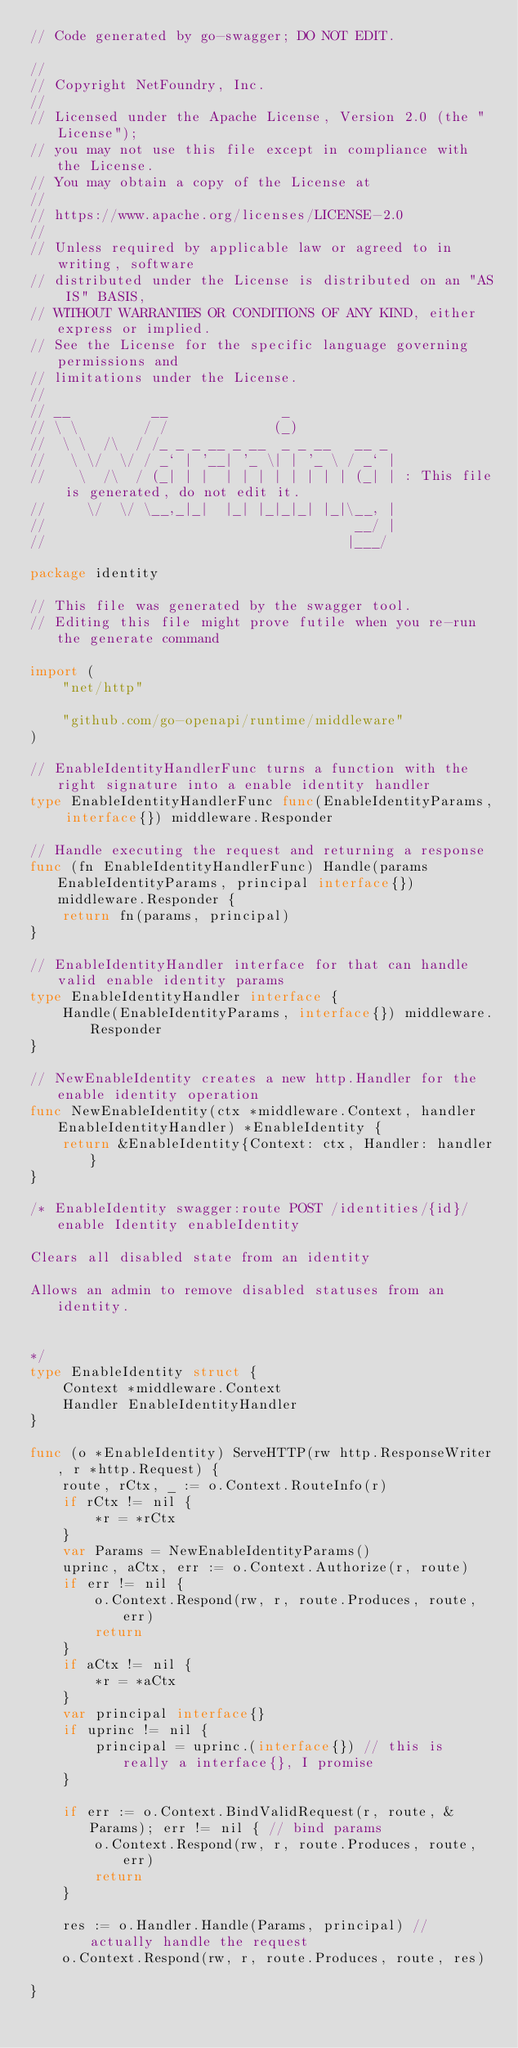Convert code to text. <code><loc_0><loc_0><loc_500><loc_500><_Go_>// Code generated by go-swagger; DO NOT EDIT.

//
// Copyright NetFoundry, Inc.
//
// Licensed under the Apache License, Version 2.0 (the "License");
// you may not use this file except in compliance with the License.
// You may obtain a copy of the License at
//
// https://www.apache.org/licenses/LICENSE-2.0
//
// Unless required by applicable law or agreed to in writing, software
// distributed under the License is distributed on an "AS IS" BASIS,
// WITHOUT WARRANTIES OR CONDITIONS OF ANY KIND, either express or implied.
// See the License for the specific language governing permissions and
// limitations under the License.
//
// __          __              _
// \ \        / /             (_)
//  \ \  /\  / /_ _ _ __ _ __  _ _ __   __ _
//   \ \/  \/ / _` | '__| '_ \| | '_ \ / _` |
//    \  /\  / (_| | |  | | | | | | | | (_| | : This file is generated, do not edit it.
//     \/  \/ \__,_|_|  |_| |_|_|_| |_|\__, |
//                                      __/ |
//                                     |___/

package identity

// This file was generated by the swagger tool.
// Editing this file might prove futile when you re-run the generate command

import (
	"net/http"

	"github.com/go-openapi/runtime/middleware"
)

// EnableIdentityHandlerFunc turns a function with the right signature into a enable identity handler
type EnableIdentityHandlerFunc func(EnableIdentityParams, interface{}) middleware.Responder

// Handle executing the request and returning a response
func (fn EnableIdentityHandlerFunc) Handle(params EnableIdentityParams, principal interface{}) middleware.Responder {
	return fn(params, principal)
}

// EnableIdentityHandler interface for that can handle valid enable identity params
type EnableIdentityHandler interface {
	Handle(EnableIdentityParams, interface{}) middleware.Responder
}

// NewEnableIdentity creates a new http.Handler for the enable identity operation
func NewEnableIdentity(ctx *middleware.Context, handler EnableIdentityHandler) *EnableIdentity {
	return &EnableIdentity{Context: ctx, Handler: handler}
}

/* EnableIdentity swagger:route POST /identities/{id}/enable Identity enableIdentity

Clears all disabled state from an identity

Allows an admin to remove disabled statuses from an identity.


*/
type EnableIdentity struct {
	Context *middleware.Context
	Handler EnableIdentityHandler
}

func (o *EnableIdentity) ServeHTTP(rw http.ResponseWriter, r *http.Request) {
	route, rCtx, _ := o.Context.RouteInfo(r)
	if rCtx != nil {
		*r = *rCtx
	}
	var Params = NewEnableIdentityParams()
	uprinc, aCtx, err := o.Context.Authorize(r, route)
	if err != nil {
		o.Context.Respond(rw, r, route.Produces, route, err)
		return
	}
	if aCtx != nil {
		*r = *aCtx
	}
	var principal interface{}
	if uprinc != nil {
		principal = uprinc.(interface{}) // this is really a interface{}, I promise
	}

	if err := o.Context.BindValidRequest(r, route, &Params); err != nil { // bind params
		o.Context.Respond(rw, r, route.Produces, route, err)
		return
	}

	res := o.Handler.Handle(Params, principal) // actually handle the request
	o.Context.Respond(rw, r, route.Produces, route, res)

}
</code> 